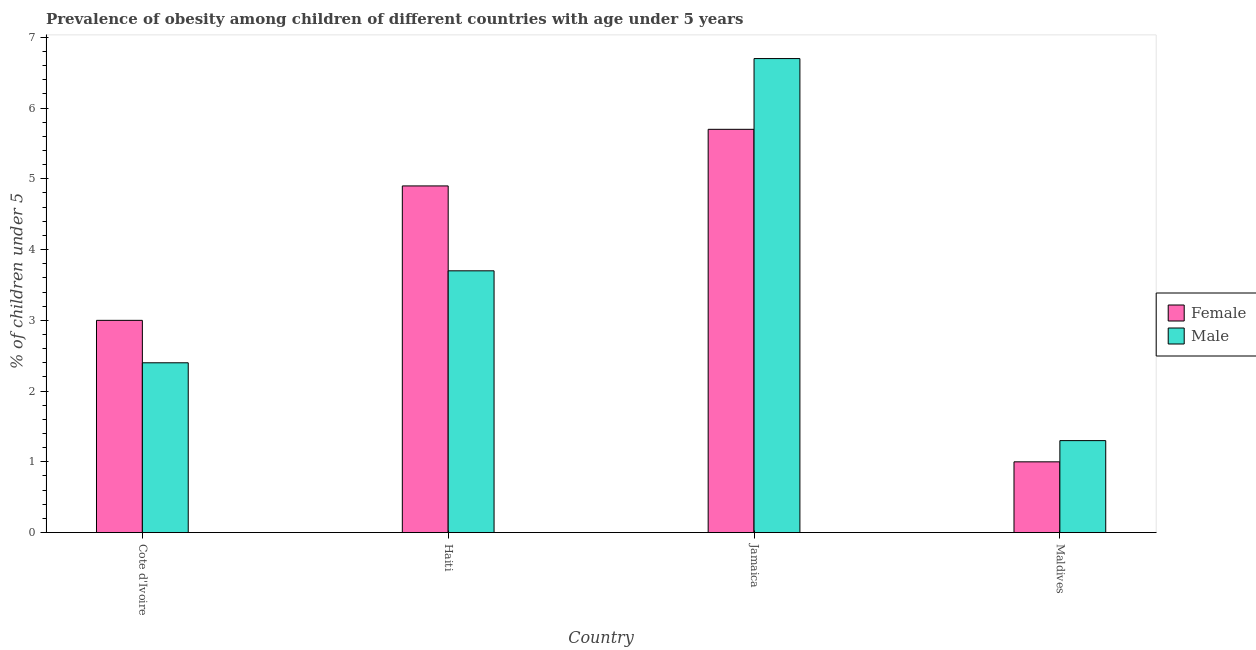Are the number of bars per tick equal to the number of legend labels?
Make the answer very short. Yes. Are the number of bars on each tick of the X-axis equal?
Your response must be concise. Yes. How many bars are there on the 2nd tick from the right?
Provide a succinct answer. 2. What is the label of the 1st group of bars from the left?
Give a very brief answer. Cote d'Ivoire. What is the percentage of obese male children in Jamaica?
Your response must be concise. 6.7. Across all countries, what is the maximum percentage of obese male children?
Ensure brevity in your answer.  6.7. Across all countries, what is the minimum percentage of obese male children?
Your response must be concise. 1.3. In which country was the percentage of obese male children maximum?
Make the answer very short. Jamaica. In which country was the percentage of obese female children minimum?
Ensure brevity in your answer.  Maldives. What is the total percentage of obese female children in the graph?
Provide a short and direct response. 14.6. What is the difference between the percentage of obese male children in Haiti and that in Maldives?
Your response must be concise. 2.4. What is the difference between the percentage of obese male children in Cote d'Ivoire and the percentage of obese female children in Jamaica?
Provide a succinct answer. -3.3. What is the average percentage of obese male children per country?
Make the answer very short. 3.52. What is the difference between the percentage of obese female children and percentage of obese male children in Jamaica?
Give a very brief answer. -1. In how many countries, is the percentage of obese female children greater than 4.6 %?
Make the answer very short. 2. What is the ratio of the percentage of obese male children in Haiti to that in Maldives?
Provide a short and direct response. 2.85. What is the difference between the highest and the second highest percentage of obese male children?
Offer a terse response. 3. What is the difference between the highest and the lowest percentage of obese female children?
Provide a short and direct response. 4.7. What does the 2nd bar from the left in Haiti represents?
Provide a short and direct response. Male. What does the 2nd bar from the right in Haiti represents?
Offer a terse response. Female. Are all the bars in the graph horizontal?
Your response must be concise. No. How many countries are there in the graph?
Provide a short and direct response. 4. What is the difference between two consecutive major ticks on the Y-axis?
Provide a succinct answer. 1. Are the values on the major ticks of Y-axis written in scientific E-notation?
Ensure brevity in your answer.  No. Does the graph contain any zero values?
Keep it short and to the point. No. Does the graph contain grids?
Provide a succinct answer. No. Where does the legend appear in the graph?
Provide a succinct answer. Center right. How many legend labels are there?
Offer a very short reply. 2. What is the title of the graph?
Make the answer very short. Prevalence of obesity among children of different countries with age under 5 years. Does "Netherlands" appear as one of the legend labels in the graph?
Give a very brief answer. No. What is the label or title of the Y-axis?
Your response must be concise.  % of children under 5. What is the  % of children under 5 in Male in Cote d'Ivoire?
Provide a succinct answer. 2.4. What is the  % of children under 5 of Female in Haiti?
Keep it short and to the point. 4.9. What is the  % of children under 5 in Male in Haiti?
Ensure brevity in your answer.  3.7. What is the  % of children under 5 in Female in Jamaica?
Give a very brief answer. 5.7. What is the  % of children under 5 in Male in Jamaica?
Provide a succinct answer. 6.7. What is the  % of children under 5 in Female in Maldives?
Provide a succinct answer. 1. What is the  % of children under 5 of Male in Maldives?
Your response must be concise. 1.3. Across all countries, what is the maximum  % of children under 5 of Female?
Keep it short and to the point. 5.7. Across all countries, what is the maximum  % of children under 5 in Male?
Your response must be concise. 6.7. Across all countries, what is the minimum  % of children under 5 in Female?
Offer a terse response. 1. Across all countries, what is the minimum  % of children under 5 of Male?
Your response must be concise. 1.3. What is the total  % of children under 5 of Female in the graph?
Your answer should be compact. 14.6. What is the total  % of children under 5 of Male in the graph?
Provide a short and direct response. 14.1. What is the difference between the  % of children under 5 of Female in Cote d'Ivoire and that in Haiti?
Your answer should be very brief. -1.9. What is the difference between the  % of children under 5 in Male in Cote d'Ivoire and that in Haiti?
Your answer should be very brief. -1.3. What is the difference between the  % of children under 5 in Female in Cote d'Ivoire and that in Jamaica?
Provide a succinct answer. -2.7. What is the difference between the  % of children under 5 of Male in Cote d'Ivoire and that in Jamaica?
Your response must be concise. -4.3. What is the difference between the  % of children under 5 in Female in Haiti and that in Jamaica?
Offer a very short reply. -0.8. What is the difference between the  % of children under 5 of Male in Haiti and that in Jamaica?
Give a very brief answer. -3. What is the difference between the  % of children under 5 in Male in Haiti and that in Maldives?
Keep it short and to the point. 2.4. What is the difference between the  % of children under 5 of Female in Jamaica and that in Maldives?
Make the answer very short. 4.7. What is the difference between the  % of children under 5 in Female in Haiti and the  % of children under 5 in Male in Jamaica?
Offer a terse response. -1.8. What is the difference between the  % of children under 5 of Female in Haiti and the  % of children under 5 of Male in Maldives?
Provide a succinct answer. 3.6. What is the average  % of children under 5 of Female per country?
Provide a succinct answer. 3.65. What is the average  % of children under 5 in Male per country?
Keep it short and to the point. 3.52. What is the difference between the  % of children under 5 in Female and  % of children under 5 in Male in Cote d'Ivoire?
Give a very brief answer. 0.6. What is the difference between the  % of children under 5 of Female and  % of children under 5 of Male in Haiti?
Keep it short and to the point. 1.2. What is the difference between the  % of children under 5 of Female and  % of children under 5 of Male in Jamaica?
Keep it short and to the point. -1. What is the difference between the  % of children under 5 of Female and  % of children under 5 of Male in Maldives?
Offer a very short reply. -0.3. What is the ratio of the  % of children under 5 of Female in Cote d'Ivoire to that in Haiti?
Provide a short and direct response. 0.61. What is the ratio of the  % of children under 5 of Male in Cote d'Ivoire to that in Haiti?
Keep it short and to the point. 0.65. What is the ratio of the  % of children under 5 of Female in Cote d'Ivoire to that in Jamaica?
Provide a short and direct response. 0.53. What is the ratio of the  % of children under 5 in Male in Cote d'Ivoire to that in Jamaica?
Provide a succinct answer. 0.36. What is the ratio of the  % of children under 5 of Female in Cote d'Ivoire to that in Maldives?
Your answer should be compact. 3. What is the ratio of the  % of children under 5 in Male in Cote d'Ivoire to that in Maldives?
Provide a succinct answer. 1.85. What is the ratio of the  % of children under 5 in Female in Haiti to that in Jamaica?
Your answer should be very brief. 0.86. What is the ratio of the  % of children under 5 of Male in Haiti to that in Jamaica?
Your answer should be compact. 0.55. What is the ratio of the  % of children under 5 of Male in Haiti to that in Maldives?
Your answer should be very brief. 2.85. What is the ratio of the  % of children under 5 in Male in Jamaica to that in Maldives?
Offer a terse response. 5.15. What is the difference between the highest and the lowest  % of children under 5 in Female?
Your answer should be very brief. 4.7. 